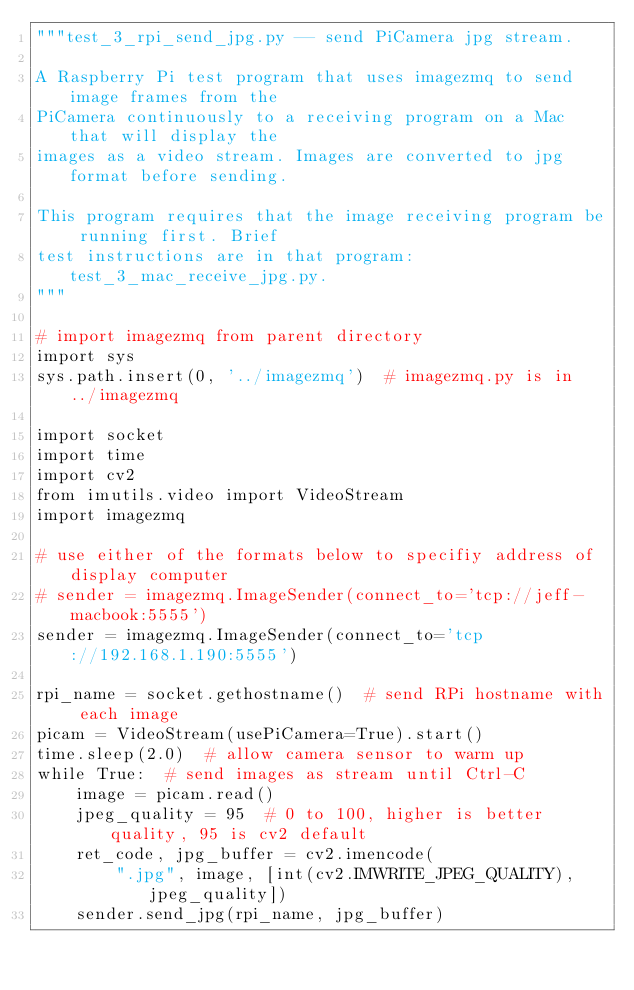<code> <loc_0><loc_0><loc_500><loc_500><_Python_>"""test_3_rpi_send_jpg.py -- send PiCamera jpg stream.

A Raspberry Pi test program that uses imagezmq to send image frames from the
PiCamera continuously to a receiving program on a Mac that will display the
images as a video stream. Images are converted to jpg format before sending.

This program requires that the image receiving program be running first. Brief
test instructions are in that program: test_3_mac_receive_jpg.py.
"""

# import imagezmq from parent directory
import sys
sys.path.insert(0, '../imagezmq')  # imagezmq.py is in ../imagezmq

import socket
import time
import cv2
from imutils.video import VideoStream
import imagezmq

# use either of the formats below to specifiy address of display computer
# sender = imagezmq.ImageSender(connect_to='tcp://jeff-macbook:5555')
sender = imagezmq.ImageSender(connect_to='tcp://192.168.1.190:5555')

rpi_name = socket.gethostname()  # send RPi hostname with each image
picam = VideoStream(usePiCamera=True).start()
time.sleep(2.0)  # allow camera sensor to warm up
while True:  # send images as stream until Ctrl-C
    image = picam.read()
    jpeg_quality = 95  # 0 to 100, higher is better quality, 95 is cv2 default
    ret_code, jpg_buffer = cv2.imencode(
        ".jpg", image, [int(cv2.IMWRITE_JPEG_QUALITY), jpeg_quality])
    sender.send_jpg(rpi_name, jpg_buffer)
</code> 